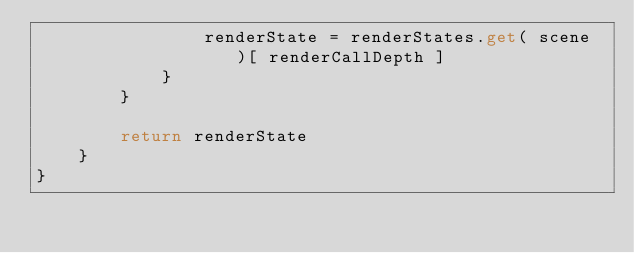<code> <loc_0><loc_0><loc_500><loc_500><_Kotlin_>                renderState = renderStates.get( scene )[ renderCallDepth ]
            }
        }

        return renderState
    }
}
</code> 